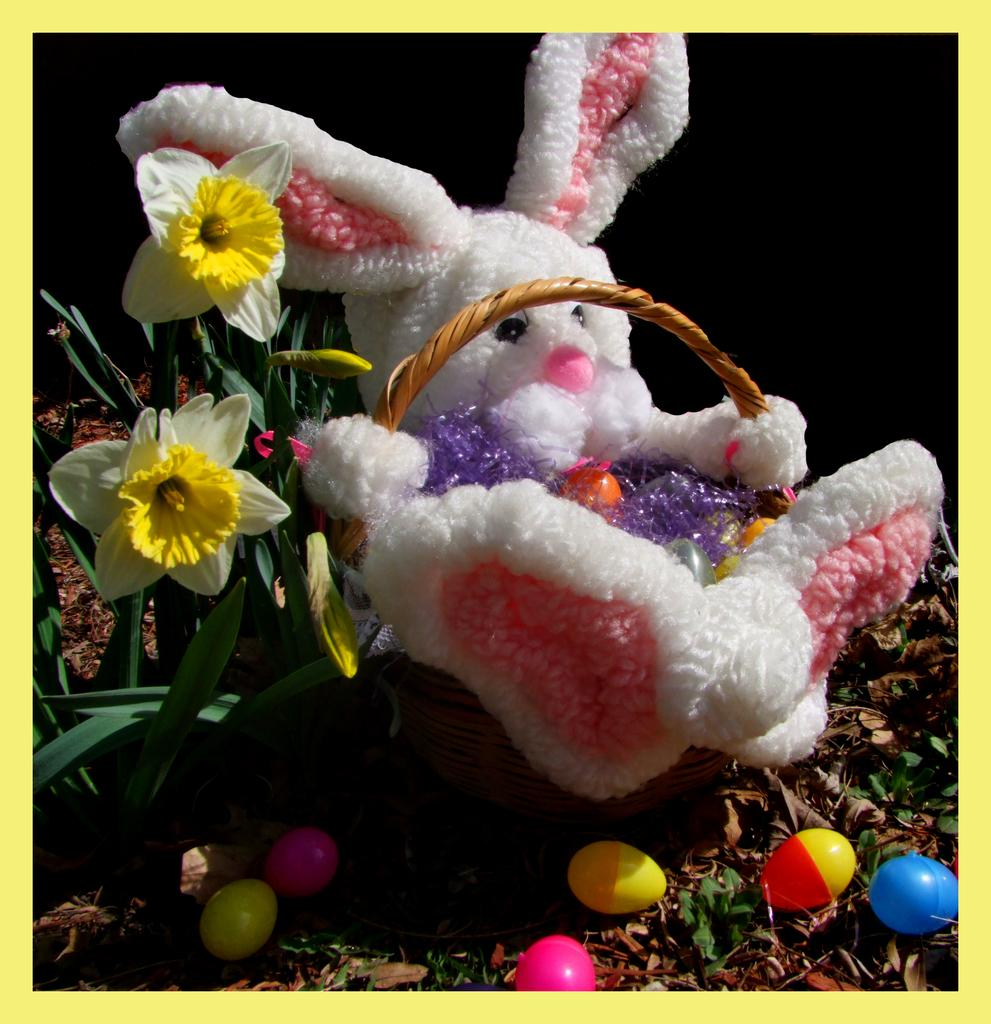What is located inside the basket in the image? There is a toy in a basket. What can be seen in the foreground of the image? There are flowers in the foreground. What type of toys are present in the image? There are colorful toy eggs in the image. What might be found at the bottom side of the image? It appears there are dry leaves at the bottom side. Can you tell me how many requests are being made in the image? There are no requests being made in the image; it features a toy in a basket, flowers, toy eggs, and dry leaves. What type of pocket is visible in the image? There is no pocket visible in the image. 